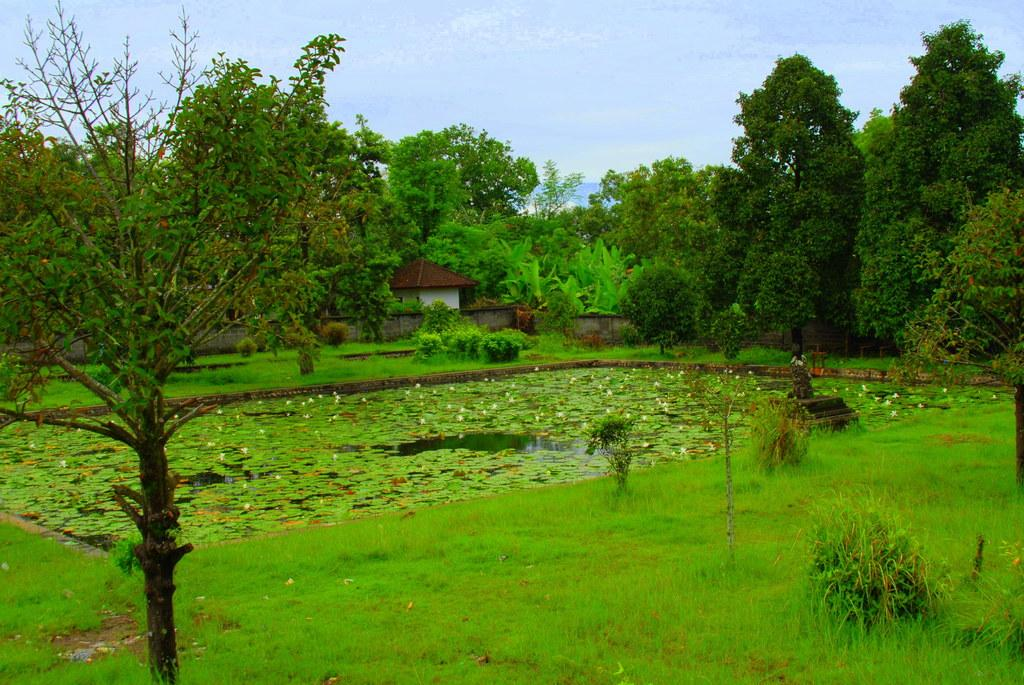What type of vegetation can be seen in the image? There are trees, sheds, a pond, grass, and plants visible in the image. What is located in the center of the image? There is a pond in the center of the image. What type of ground surface is present at the bottom of the image? There is grass at the bottom of the image. What can be seen in the background of the image? The sky is visible in the background of the image. Can you tell me how many skates are on the pond in the image? There are no skates present on the pond in the image. What type of afterthought is depicted in the image? There is no afterthought depicted in the image; it features natural elements such as trees, sheds, a pond, grass, plants, and the sky. 